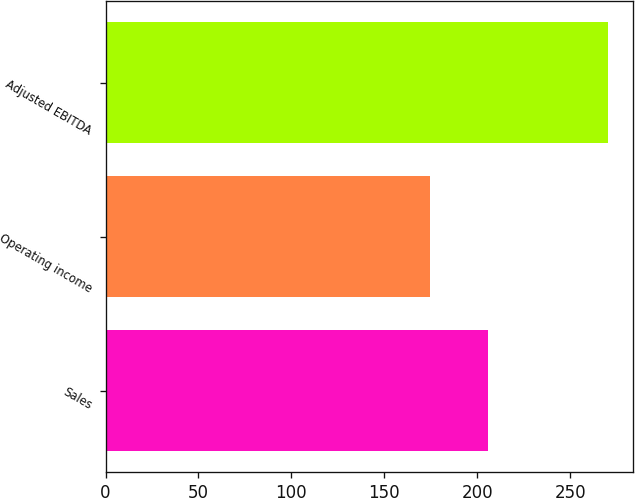Convert chart to OTSL. <chart><loc_0><loc_0><loc_500><loc_500><bar_chart><fcel>Sales<fcel>Operating income<fcel>Adjusted EBITDA<nl><fcel>205.6<fcel>174.3<fcel>270.1<nl></chart> 